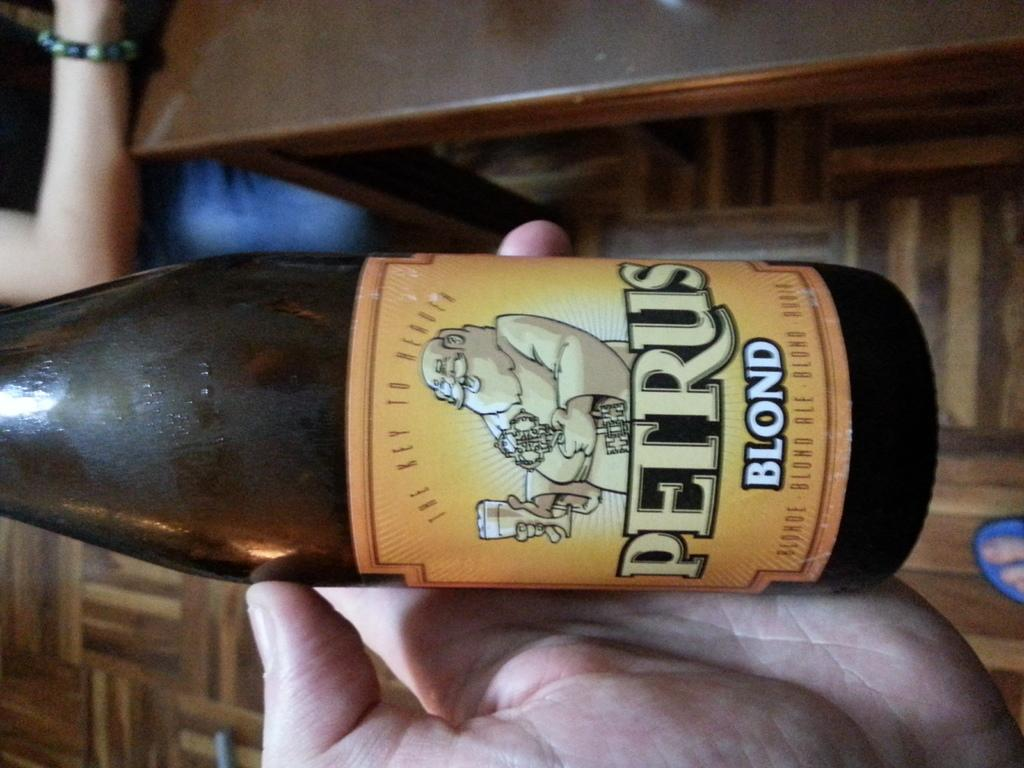<image>
Share a concise interpretation of the image provided. Someone is holding a bottle of Petru blond beer in their hand. 